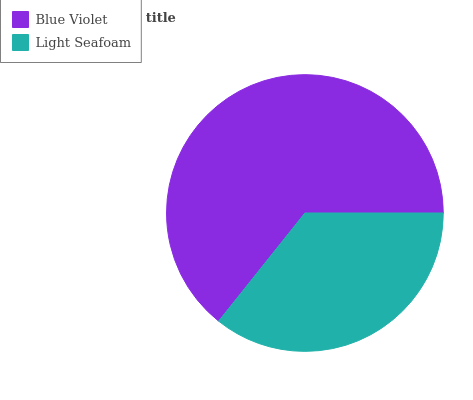Is Light Seafoam the minimum?
Answer yes or no. Yes. Is Blue Violet the maximum?
Answer yes or no. Yes. Is Light Seafoam the maximum?
Answer yes or no. No. Is Blue Violet greater than Light Seafoam?
Answer yes or no. Yes. Is Light Seafoam less than Blue Violet?
Answer yes or no. Yes. Is Light Seafoam greater than Blue Violet?
Answer yes or no. No. Is Blue Violet less than Light Seafoam?
Answer yes or no. No. Is Blue Violet the high median?
Answer yes or no. Yes. Is Light Seafoam the low median?
Answer yes or no. Yes. Is Light Seafoam the high median?
Answer yes or no. No. Is Blue Violet the low median?
Answer yes or no. No. 